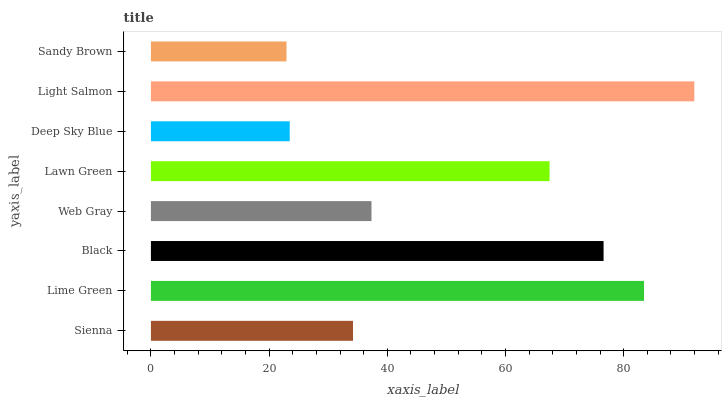Is Sandy Brown the minimum?
Answer yes or no. Yes. Is Light Salmon the maximum?
Answer yes or no. Yes. Is Lime Green the minimum?
Answer yes or no. No. Is Lime Green the maximum?
Answer yes or no. No. Is Lime Green greater than Sienna?
Answer yes or no. Yes. Is Sienna less than Lime Green?
Answer yes or no. Yes. Is Sienna greater than Lime Green?
Answer yes or no. No. Is Lime Green less than Sienna?
Answer yes or no. No. Is Lawn Green the high median?
Answer yes or no. Yes. Is Web Gray the low median?
Answer yes or no. Yes. Is Lime Green the high median?
Answer yes or no. No. Is Lime Green the low median?
Answer yes or no. No. 